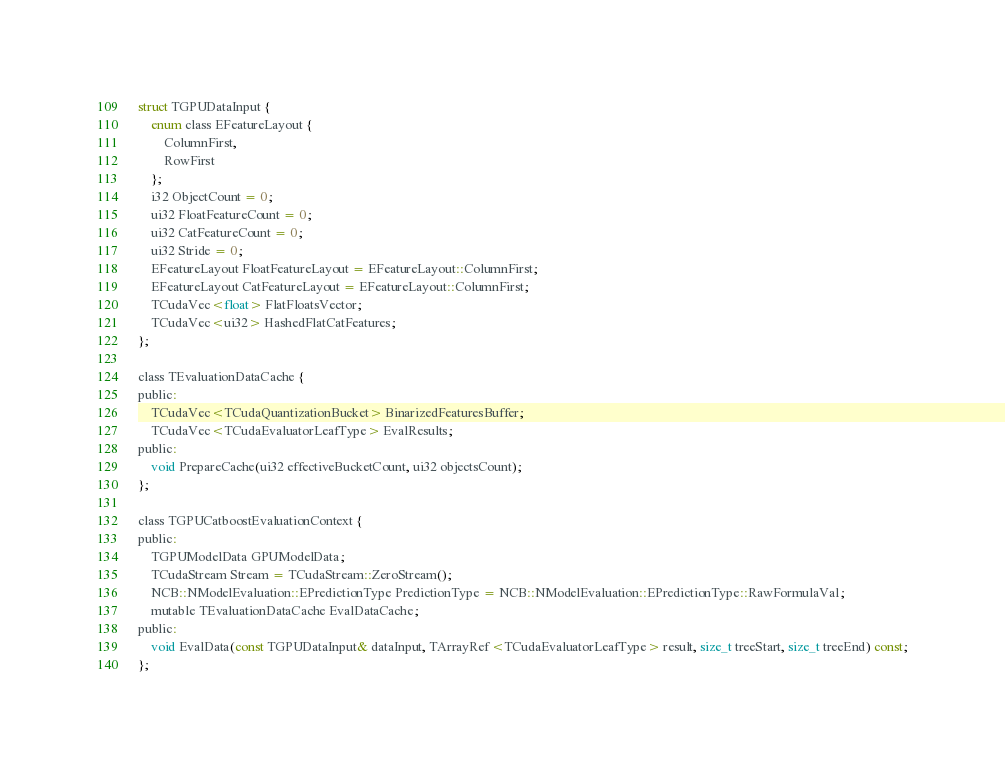Convert code to text. <code><loc_0><loc_0><loc_500><loc_500><_Cuda_>
struct TGPUDataInput {
    enum class EFeatureLayout {
        ColumnFirst,
        RowFirst
    };
    i32 ObjectCount = 0;
    ui32 FloatFeatureCount = 0;
    ui32 CatFeatureCount = 0;
    ui32 Stride = 0;
    EFeatureLayout FloatFeatureLayout = EFeatureLayout::ColumnFirst;
    EFeatureLayout CatFeatureLayout = EFeatureLayout::ColumnFirst;
    TCudaVec<float> FlatFloatsVector;
    TCudaVec<ui32> HashedFlatCatFeatures;
};

class TEvaluationDataCache {
public:
    TCudaVec<TCudaQuantizationBucket> BinarizedFeaturesBuffer;
    TCudaVec<TCudaEvaluatorLeafType> EvalResults;
public:
    void PrepareCache(ui32 effectiveBucketCount, ui32 objectsCount);
};

class TGPUCatboostEvaluationContext {
public:
    TGPUModelData GPUModelData;
    TCudaStream Stream = TCudaStream::ZeroStream();
    NCB::NModelEvaluation::EPredictionType PredictionType = NCB::NModelEvaluation::EPredictionType::RawFormulaVal;
    mutable TEvaluationDataCache EvalDataCache;
public:
    void EvalData(const TGPUDataInput& dataInput, TArrayRef<TCudaEvaluatorLeafType> result, size_t treeStart, size_t treeEnd) const;
};
</code> 